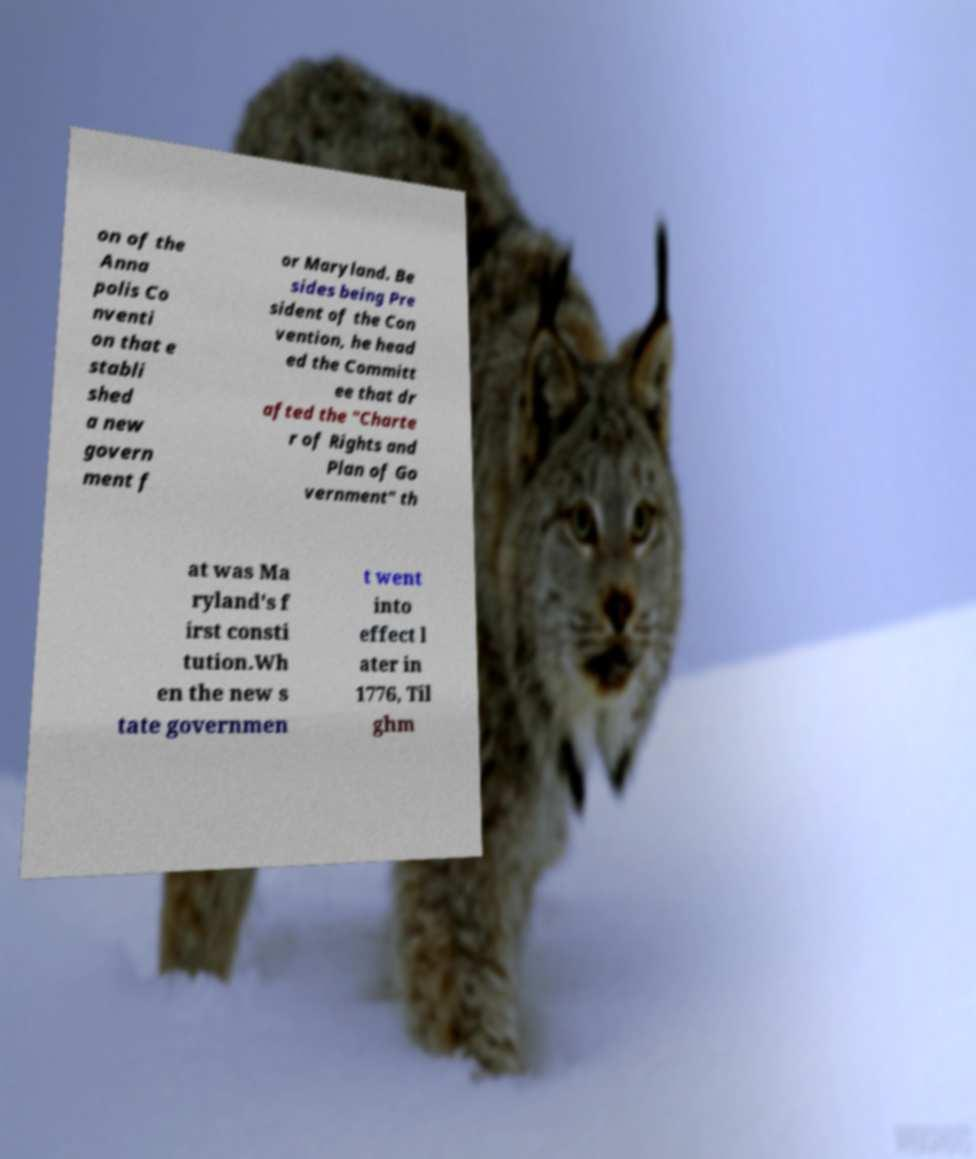I need the written content from this picture converted into text. Can you do that? on of the Anna polis Co nventi on that e stabli shed a new govern ment f or Maryland. Be sides being Pre sident of the Con vention, he head ed the Committ ee that dr afted the "Charte r of Rights and Plan of Go vernment" th at was Ma ryland's f irst consti tution.Wh en the new s tate governmen t went into effect l ater in 1776, Til ghm 